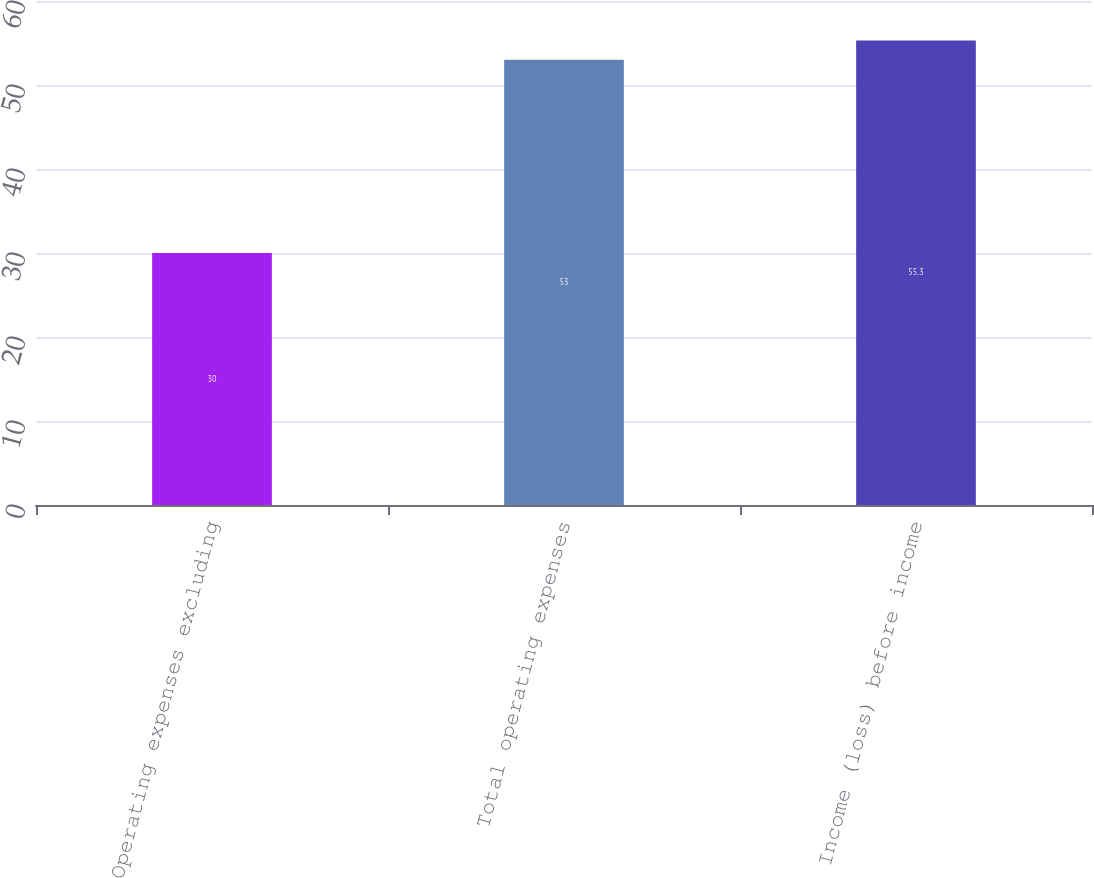Convert chart to OTSL. <chart><loc_0><loc_0><loc_500><loc_500><bar_chart><fcel>Operating expenses excluding<fcel>Total operating expenses<fcel>Income (loss) before income<nl><fcel>30<fcel>53<fcel>55.3<nl></chart> 